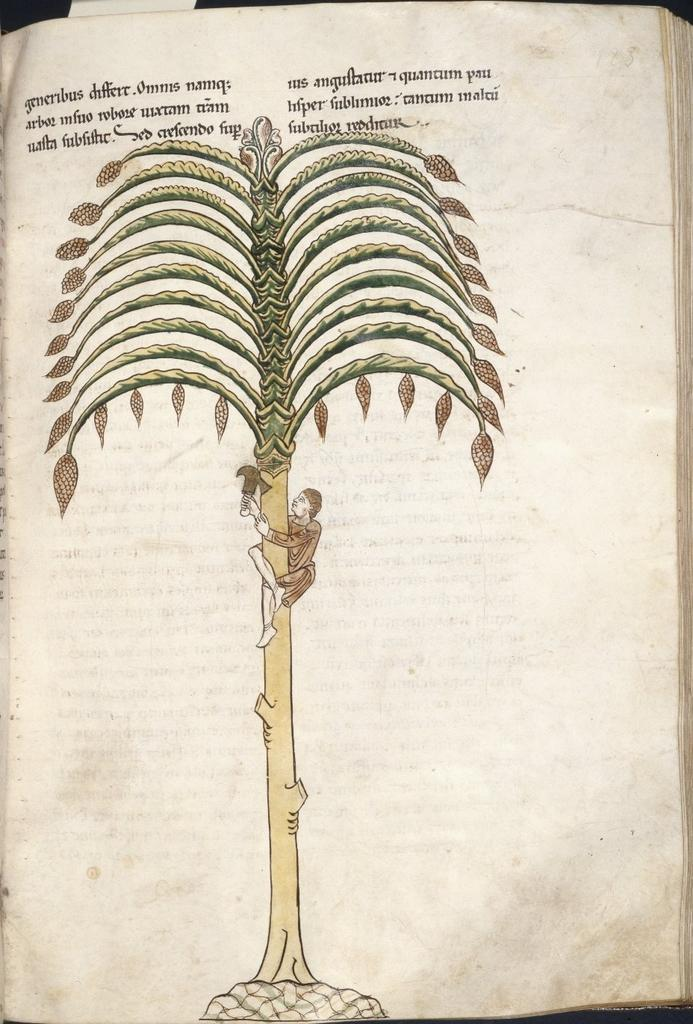What is the main object in the image? There is a book in the image. What can be seen on a specific page of the book? The book has a page with a man on it. What is the man doing in the image? The man is sitting on a tree. What is the man holding in the image? The man is holding objects. What is written on the top of the page with the man? There is text written on the top of the page. Can you see any ships in the harbor in the image? There is no harbor or ship present in the image; it features a book with a man on a tree. 